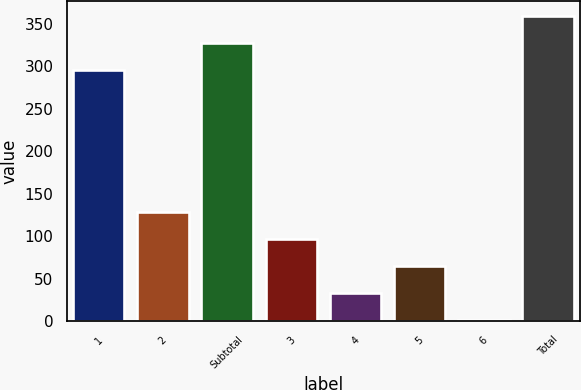Convert chart. <chart><loc_0><loc_0><loc_500><loc_500><bar_chart><fcel>1<fcel>2<fcel>Subtotal<fcel>3<fcel>4<fcel>5<fcel>6<fcel>Total<nl><fcel>295<fcel>128.77<fcel>326.87<fcel>96.9<fcel>33.16<fcel>65.03<fcel>1.29<fcel>358.74<nl></chart> 